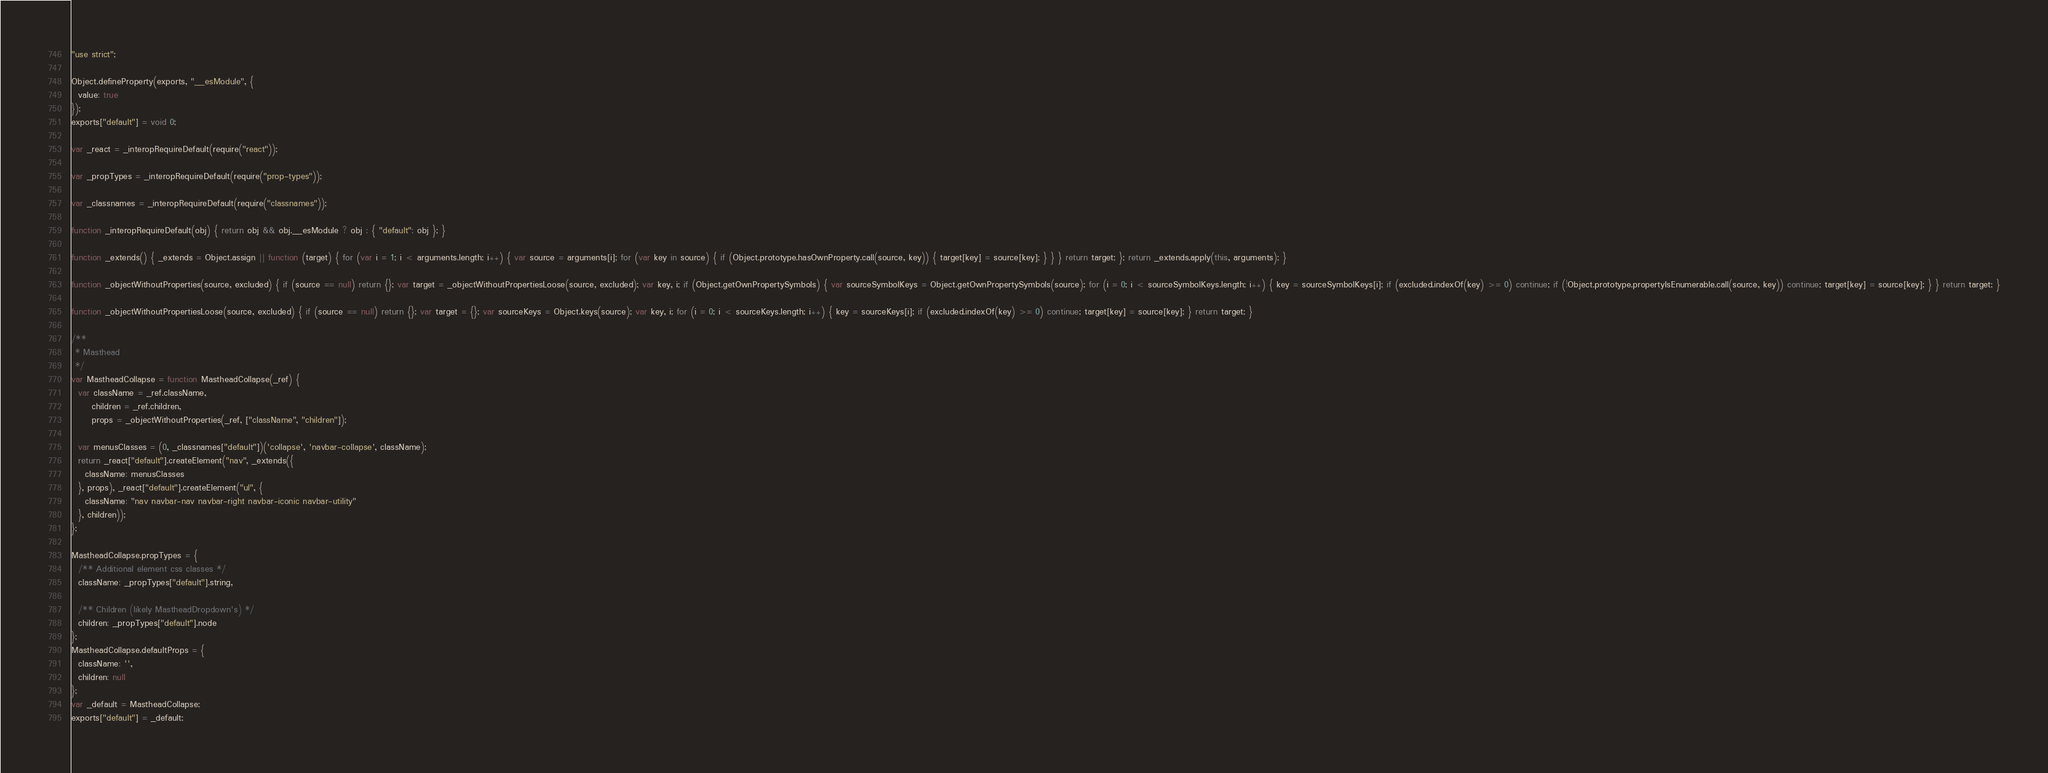<code> <loc_0><loc_0><loc_500><loc_500><_JavaScript_>"use strict";

Object.defineProperty(exports, "__esModule", {
  value: true
});
exports["default"] = void 0;

var _react = _interopRequireDefault(require("react"));

var _propTypes = _interopRequireDefault(require("prop-types"));

var _classnames = _interopRequireDefault(require("classnames"));

function _interopRequireDefault(obj) { return obj && obj.__esModule ? obj : { "default": obj }; }

function _extends() { _extends = Object.assign || function (target) { for (var i = 1; i < arguments.length; i++) { var source = arguments[i]; for (var key in source) { if (Object.prototype.hasOwnProperty.call(source, key)) { target[key] = source[key]; } } } return target; }; return _extends.apply(this, arguments); }

function _objectWithoutProperties(source, excluded) { if (source == null) return {}; var target = _objectWithoutPropertiesLoose(source, excluded); var key, i; if (Object.getOwnPropertySymbols) { var sourceSymbolKeys = Object.getOwnPropertySymbols(source); for (i = 0; i < sourceSymbolKeys.length; i++) { key = sourceSymbolKeys[i]; if (excluded.indexOf(key) >= 0) continue; if (!Object.prototype.propertyIsEnumerable.call(source, key)) continue; target[key] = source[key]; } } return target; }

function _objectWithoutPropertiesLoose(source, excluded) { if (source == null) return {}; var target = {}; var sourceKeys = Object.keys(source); var key, i; for (i = 0; i < sourceKeys.length; i++) { key = sourceKeys[i]; if (excluded.indexOf(key) >= 0) continue; target[key] = source[key]; } return target; }

/**
 * Masthead
 */
var MastheadCollapse = function MastheadCollapse(_ref) {
  var className = _ref.className,
      children = _ref.children,
      props = _objectWithoutProperties(_ref, ["className", "children"]);

  var menusClasses = (0, _classnames["default"])('collapse', 'navbar-collapse', className);
  return _react["default"].createElement("nav", _extends({
    className: menusClasses
  }, props), _react["default"].createElement("ul", {
    className: "nav navbar-nav navbar-right navbar-iconic navbar-utility"
  }, children));
};

MastheadCollapse.propTypes = {
  /** Additional element css classes */
  className: _propTypes["default"].string,

  /** Children (likely MastheadDropdown's) */
  children: _propTypes["default"].node
};
MastheadCollapse.defaultProps = {
  className: '',
  children: null
};
var _default = MastheadCollapse;
exports["default"] = _default;</code> 